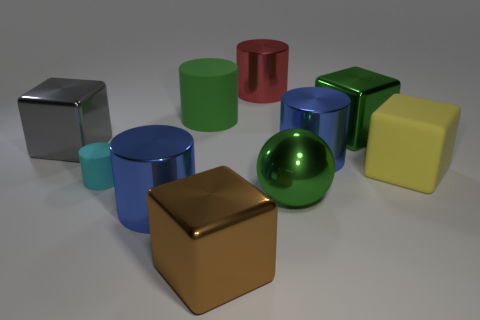There is a yellow matte thing that is the same shape as the brown shiny object; what size is it?
Your answer should be compact. Large. There is a green thing that is on the left side of the brown block; is its size the same as the small cylinder?
Provide a short and direct response. No. How many other things are there of the same color as the large metallic ball?
Ensure brevity in your answer.  2. What is the green ball made of?
Your answer should be very brief. Metal. There is a big object that is both in front of the small cyan rubber thing and to the left of the large brown shiny cube; what is its material?
Provide a short and direct response. Metal. How many objects are blue metallic things to the left of the big green rubber object or big yellow rubber cylinders?
Give a very brief answer. 1. Do the sphere and the large matte cylinder have the same color?
Offer a very short reply. Yes. Is there a yellow matte block that has the same size as the red metal object?
Keep it short and to the point. Yes. How many cubes are both on the left side of the large green metal sphere and to the right of the small cyan object?
Keep it short and to the point. 1. There is a big brown block; how many blocks are on the left side of it?
Provide a short and direct response. 1. 